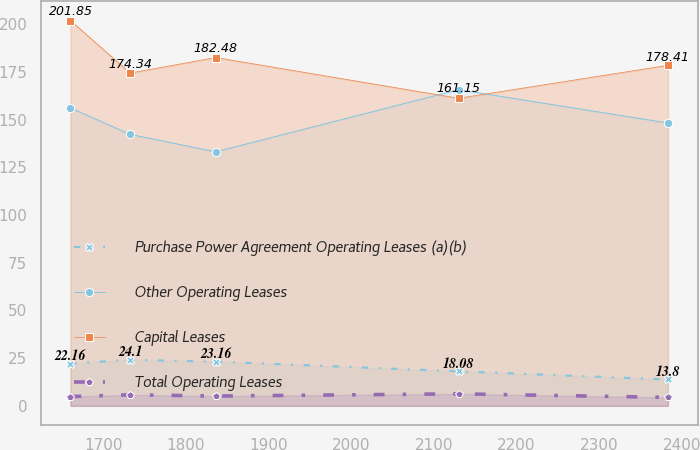Convert chart to OTSL. <chart><loc_0><loc_0><loc_500><loc_500><line_chart><ecel><fcel>Purchase Power Agreement Operating Leases (a)(b)<fcel>Other Operating Leases<fcel>Capital Leases<fcel>Total Operating Leases<nl><fcel>1660.53<fcel>22.16<fcel>156.12<fcel>201.85<fcel>4.84<nl><fcel>1732.82<fcel>24.1<fcel>142.21<fcel>174.34<fcel>5.77<nl><fcel>1836.32<fcel>23.16<fcel>133.09<fcel>182.48<fcel>5.12<nl><fcel>2130.15<fcel>18.08<fcel>165.64<fcel>161.15<fcel>6.28<nl><fcel>2383.39<fcel>13.8<fcel>148.17<fcel>178.41<fcel>4.42<nl></chart> 